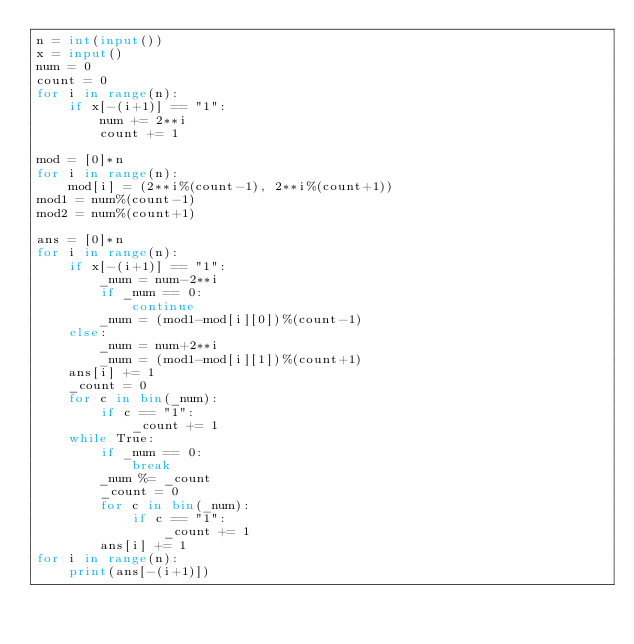Convert code to text. <code><loc_0><loc_0><loc_500><loc_500><_Python_>n = int(input())
x = input()
num = 0
count = 0
for i in range(n):
    if x[-(i+1)] == "1":
        num += 2**i
        count += 1

mod = [0]*n
for i in range(n):
    mod[i] = (2**i%(count-1), 2**i%(count+1))
mod1 = num%(count-1)
mod2 = num%(count+1)

ans = [0]*n
for i in range(n):
    if x[-(i+1)] == "1":
        _num = num-2**i
        if _num == 0:
            continue
        _num = (mod1-mod[i][0])%(count-1)
    else:
        _num = num+2**i
        _num = (mod1-mod[i][1])%(count+1)
    ans[i] += 1
    _count = 0
    for c in bin(_num):
        if c == "1":
            _count += 1
    while True:
        if _num == 0:
            break
        _num %= _count
        _count = 0
        for c in bin(_num):
            if c == "1":
                _count += 1
        ans[i] += 1
for i in range(n):
    print(ans[-(i+1)])</code> 